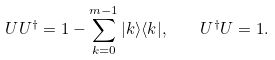Convert formula to latex. <formula><loc_0><loc_0><loc_500><loc_500>U U ^ { \dagger } = 1 - \sum _ { k = 0 } ^ { m - 1 } | k \rangle \langle k | , \quad U ^ { \dagger } U = 1 .</formula> 